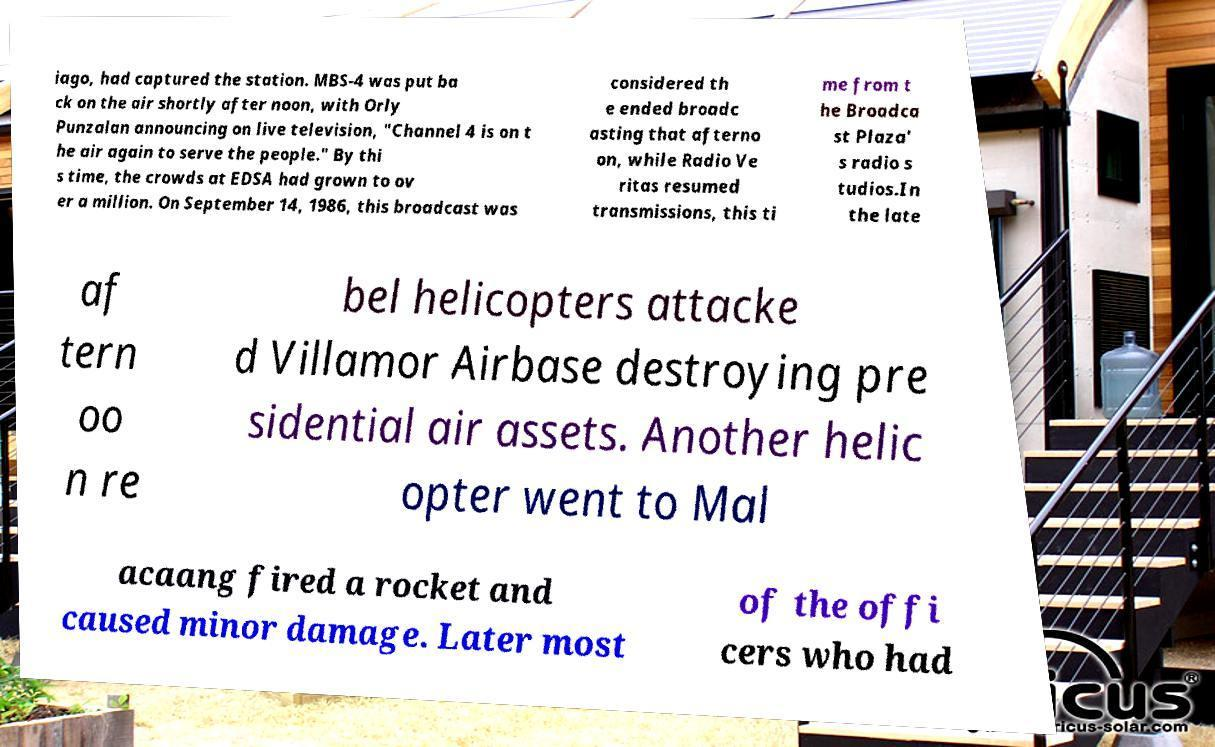There's text embedded in this image that I need extracted. Can you transcribe it verbatim? iago, had captured the station. MBS-4 was put ba ck on the air shortly after noon, with Orly Punzalan announcing on live television, "Channel 4 is on t he air again to serve the people." By thi s time, the crowds at EDSA had grown to ov er a million. On September 14, 1986, this broadcast was considered th e ended broadc asting that afterno on, while Radio Ve ritas resumed transmissions, this ti me from t he Broadca st Plaza' s radio s tudios.In the late af tern oo n re bel helicopters attacke d Villamor Airbase destroying pre sidential air assets. Another helic opter went to Mal acaang fired a rocket and caused minor damage. Later most of the offi cers who had 